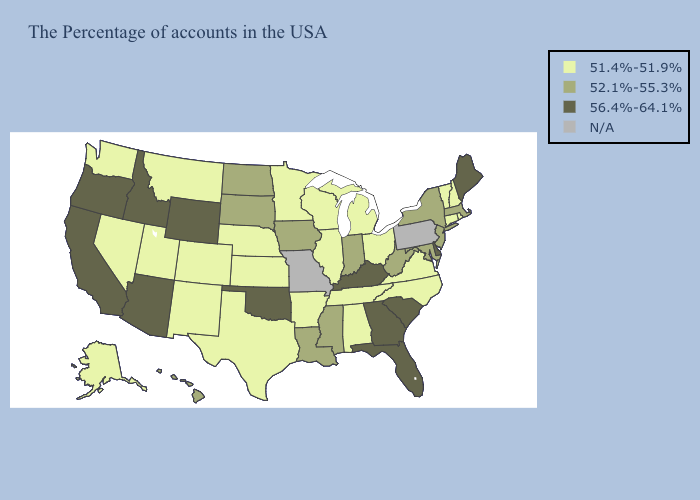What is the highest value in states that border Iowa?
Quick response, please. 52.1%-55.3%. What is the highest value in states that border Georgia?
Short answer required. 56.4%-64.1%. Does the map have missing data?
Quick response, please. Yes. What is the value of North Dakota?
Concise answer only. 52.1%-55.3%. Which states have the lowest value in the West?
Quick response, please. Colorado, New Mexico, Utah, Montana, Nevada, Washington, Alaska. What is the value of South Carolina?
Be succinct. 56.4%-64.1%. Among the states that border Georgia , does North Carolina have the lowest value?
Short answer required. Yes. Name the states that have a value in the range 56.4%-64.1%?
Short answer required. Maine, Delaware, South Carolina, Florida, Georgia, Kentucky, Oklahoma, Wyoming, Arizona, Idaho, California, Oregon. What is the value of Nevada?
Be succinct. 51.4%-51.9%. What is the value of Texas?
Give a very brief answer. 51.4%-51.9%. What is the lowest value in states that border Arkansas?
Write a very short answer. 51.4%-51.9%. What is the highest value in the South ?
Keep it brief. 56.4%-64.1%. Which states have the highest value in the USA?
Give a very brief answer. Maine, Delaware, South Carolina, Florida, Georgia, Kentucky, Oklahoma, Wyoming, Arizona, Idaho, California, Oregon. 